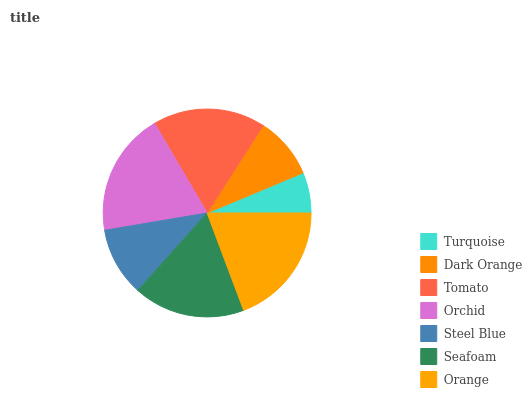Is Turquoise the minimum?
Answer yes or no. Yes. Is Orange the maximum?
Answer yes or no. Yes. Is Dark Orange the minimum?
Answer yes or no. No. Is Dark Orange the maximum?
Answer yes or no. No. Is Dark Orange greater than Turquoise?
Answer yes or no. Yes. Is Turquoise less than Dark Orange?
Answer yes or no. Yes. Is Turquoise greater than Dark Orange?
Answer yes or no. No. Is Dark Orange less than Turquoise?
Answer yes or no. No. Is Seafoam the high median?
Answer yes or no. Yes. Is Seafoam the low median?
Answer yes or no. Yes. Is Tomato the high median?
Answer yes or no. No. Is Orange the low median?
Answer yes or no. No. 